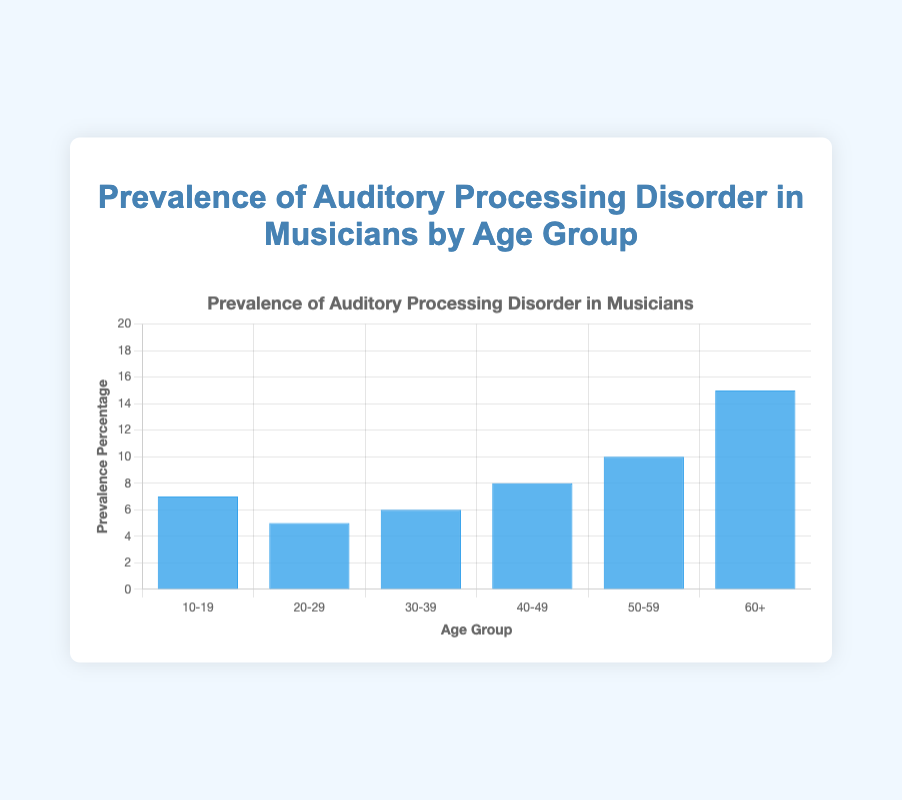What is the prevalence percentage for the age group 50-59? From the chart, we can see the height of the bar corresponds to the prevalence percentage for each age group. The bar for the age group 50-59 is at 10%.
Answer: 10% Which age group has the highest prevalence of Auditory Processing Disorder? By comparing the heights of the bars for each age group, the age group 60+ has the tallest bar.
Answer: 60+ What is the difference in prevalence percentage between the age groups 20-29 and 60+? The prevalence percentage for the age group 20-29 is 5%, whereas for the age group 60+ it is 15%. The difference is 15% - 5% = 10%.
Answer: 10% How many age groups have a prevalence percentage greater than 7%? The age groups 40-49, 50-59, and 60+ have prevalence percentages of 8%, 10%, and 15%, respectively. So, there are 3 such age groups.
Answer: 3 What is the average prevalence percentage across all age groups? Sum the prevalence percentages: 7% + 5% + 6% + 8% + 10% + 15% = 51%. There are 6 age groups, so the average is 51% / 6 = 8.5%.
Answer: 8.5% Is the prevalence percentage of the age group 30-39 greater than that of the age group 20-29? The prevalence percentage for the age group 30-39 is 6%, while for the age group 20-29 it is 5%. Since 6% is greater than 5%, the answer is yes.
Answer: Yes Which two consecutive age groups have the smallest difference in prevalence percentage, and what is the difference? The differences are: (7%-5%)=2%, (6%-5%)=1%, (8%-6%)=2%, (10%-8%)=2%, (15%-10%)=5%. The smallest difference is between age groups 20-29 and 30-39, with a difference of 1%.
Answer: 20-29 and 30-39, 1% What percentage of age groups have a prevalence percentage of less than 10%? Out of the 6 age groups, 4 age groups (10-19: 7%, 20-29: 5%, 30-39: 6%, 40-49: 8%) have a prevalence percentage of less than 10%. So, the percentage is (4/6) * 100 = 66.67%.
Answer: 66.67% How many percentage points higher is the prevalence percentage of the age group 60+ compared to the average prevalence percentage? Average prevalence percentage is 8.5%. The prevalence percentage for the age group 60+ is 15%. The difference is 15% - 8.5% = 6.5%.
Answer: 6.5% 